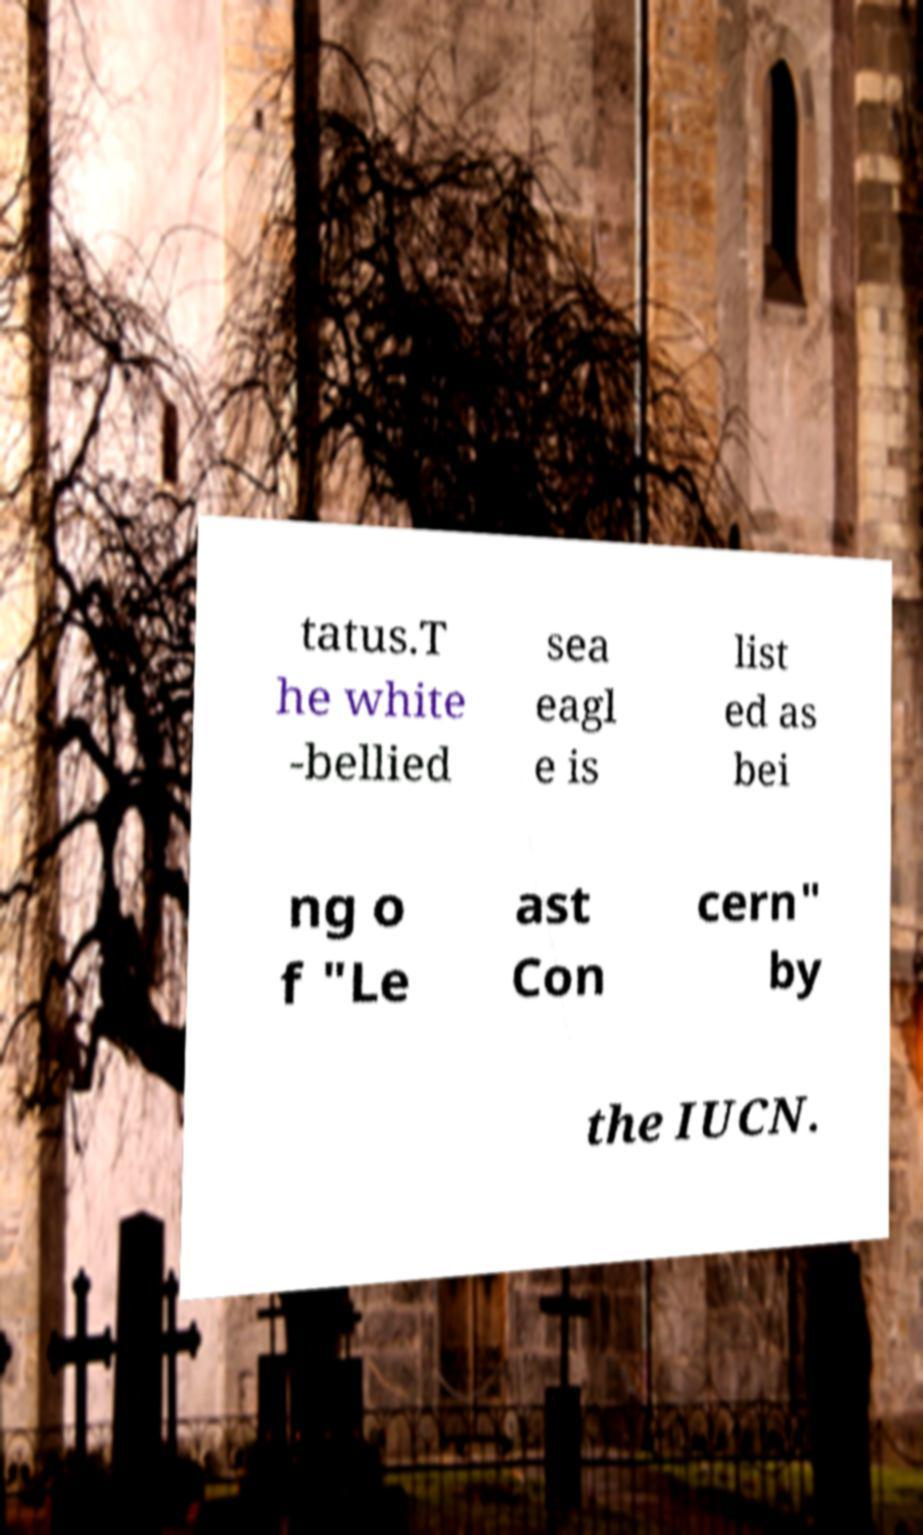Can you read and provide the text displayed in the image?This photo seems to have some interesting text. Can you extract and type it out for me? tatus.T he white -bellied sea eagl e is list ed as bei ng o f "Le ast Con cern" by the IUCN. 